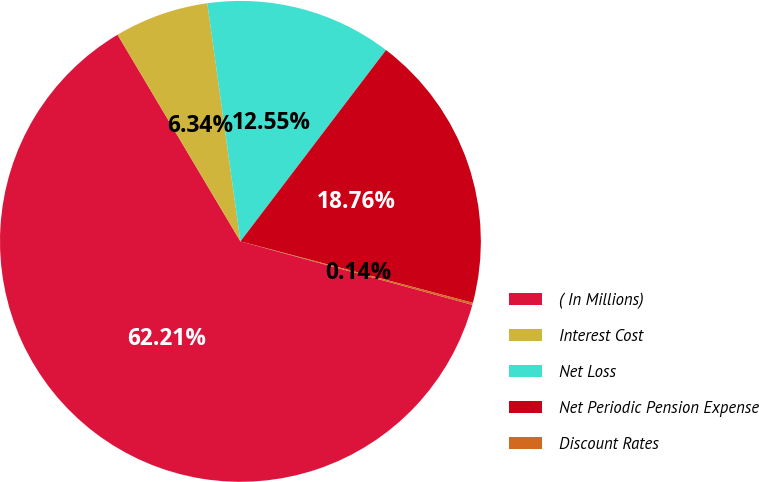Convert chart. <chart><loc_0><loc_0><loc_500><loc_500><pie_chart><fcel>( In Millions)<fcel>Interest Cost<fcel>Net Loss<fcel>Net Periodic Pension Expense<fcel>Discount Rates<nl><fcel>62.21%<fcel>6.34%<fcel>12.55%<fcel>18.76%<fcel>0.14%<nl></chart> 